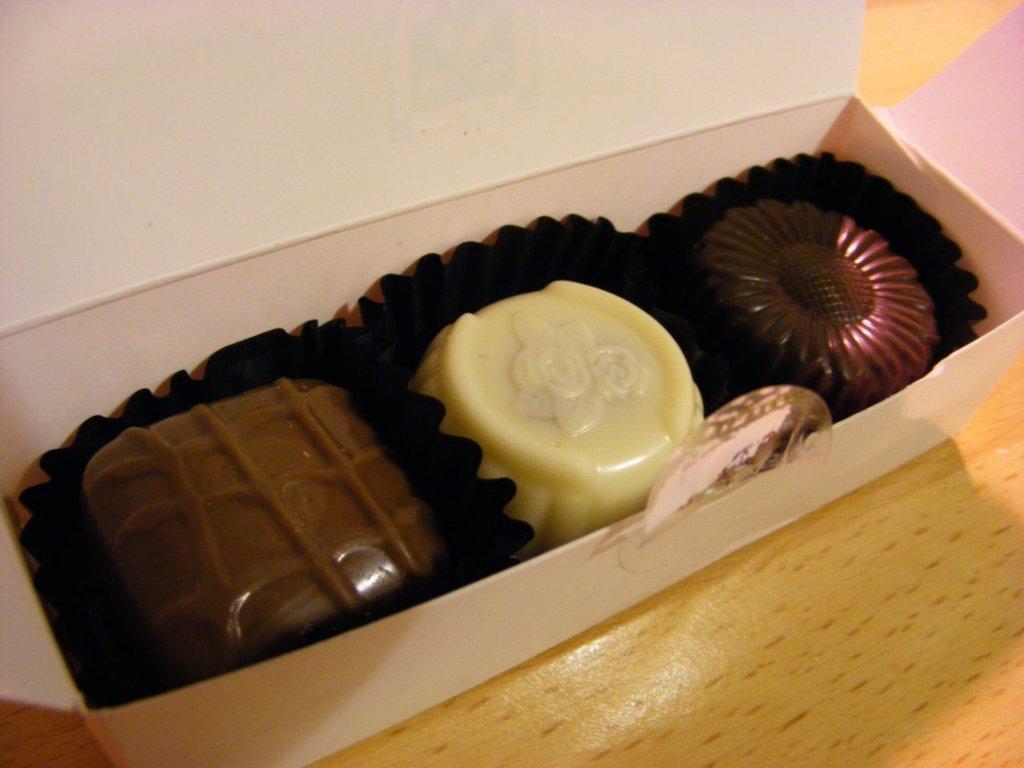Please provide a concise description of this image. In this image there is a box on a wooden plank. Box is having some chocolates on a paper. 